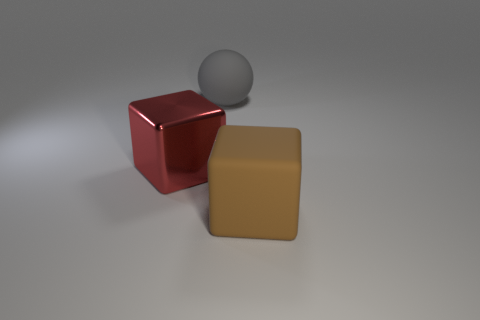What number of other objects are the same size as the rubber sphere?
Keep it short and to the point. 2. Is the size of the matte cube the same as the rubber thing behind the shiny cube?
Your answer should be very brief. Yes. What is the color of the rubber cube that is the same size as the red metal cube?
Provide a succinct answer. Brown. How big is the red shiny object?
Make the answer very short. Large. Do the big thing in front of the big shiny block and the gray ball have the same material?
Your answer should be compact. Yes. Does the shiny object have the same shape as the large gray object?
Make the answer very short. No. There is a object that is on the right side of the big matte thing that is to the left of the big block to the right of the big gray matte thing; what shape is it?
Offer a terse response. Cube. Do the thing in front of the shiny object and the big matte thing behind the big red cube have the same shape?
Your answer should be compact. No. Are there any spheres made of the same material as the large gray thing?
Your answer should be very brief. No. What color is the thing behind the large cube behind the thing right of the big ball?
Make the answer very short. Gray. 